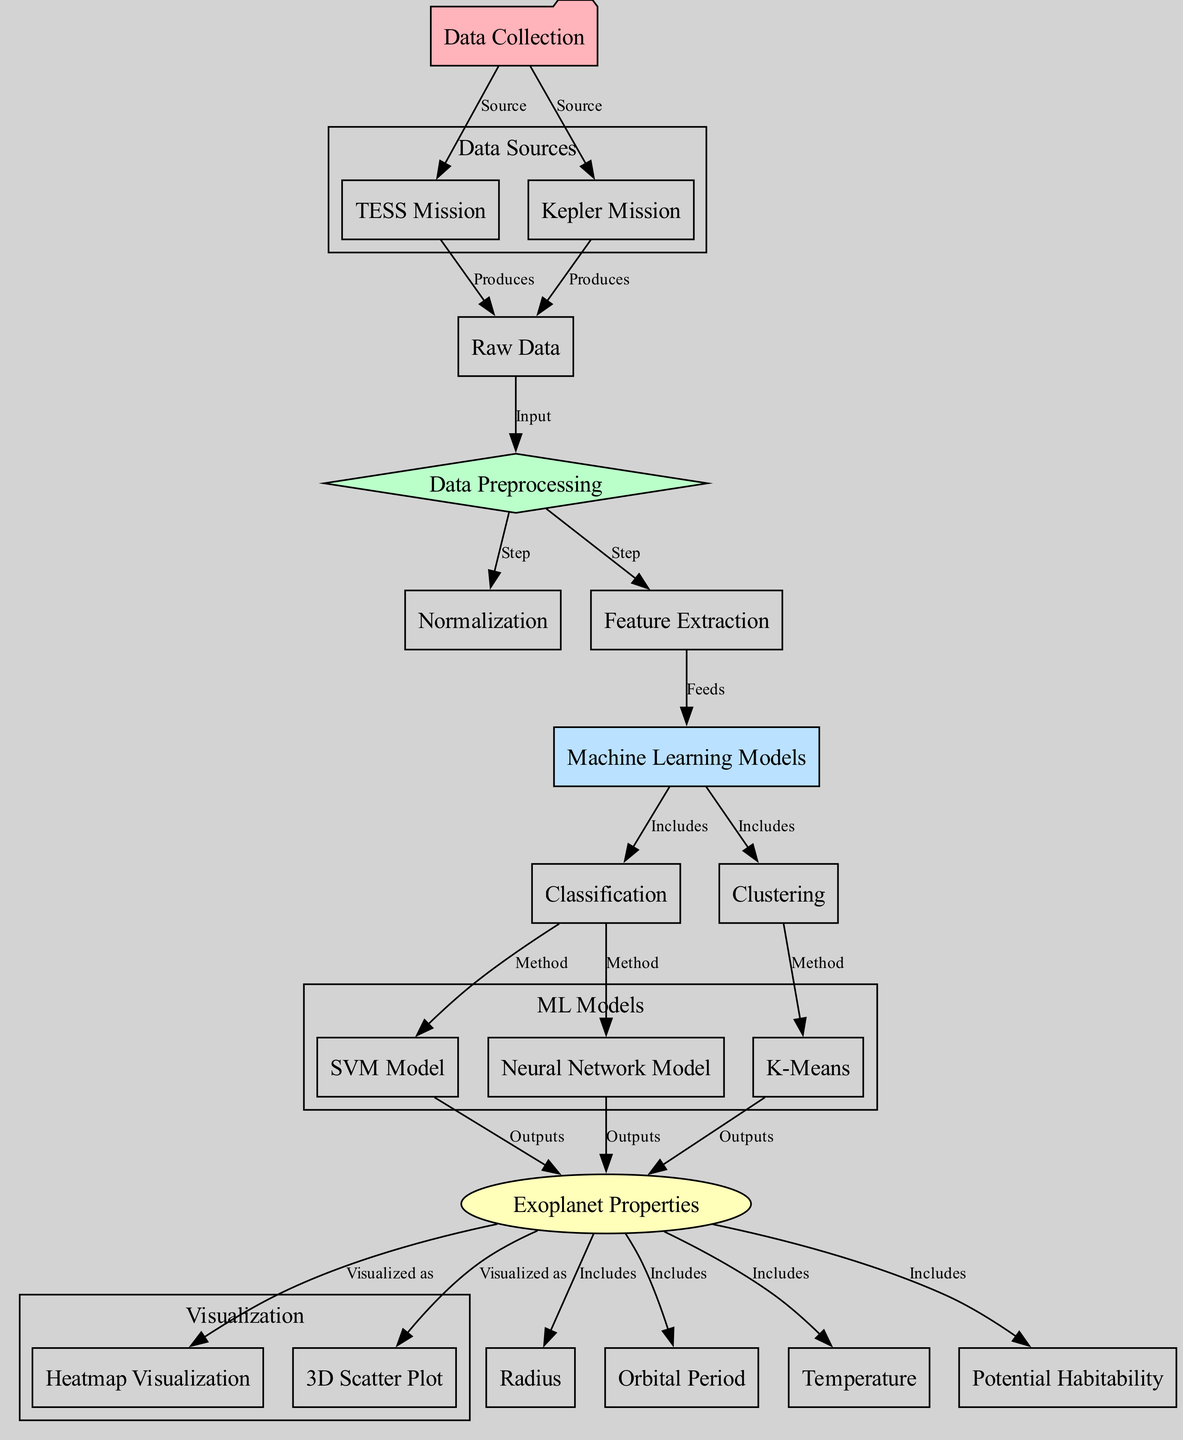What are the two main data sources represented in the diagram? The diagram lists the TESS Mission and Kepler Mission as data sources under the "Data Sources" subgraph, indicating they are the origins of the data collected for exoplanets.
Answer: TESS Mission, Kepler Mission How many nodes are present in the diagram? By counting all the nodes listed in the provided data, we find there are a total of 17 nodes related to the processes of data collection, preprocessing, machine learning models, and visualization.
Answer: 17 What is the preprocessing step that follows after raw data? The diagram indicates that after raw data is collected, it goes to the preprocessing step, which is shown as a direct connection indicating the flow of data.
Answer: Preprocessing Which machine learning model is classified as a clustering method? The diagram identifies the K-Means as a specific clustering method under the machine learning models section, as indicated by the directed edge linking clustering to K-Means.
Answer: K-Means How many output visualizations are produced from exoplanet properties? According to the diagram, the exoplanet properties lead to two visualization methods: heatmap visualization and 3D scatter plot, indicating multiple outputs from processed data.
Answer: 2 What is the classification method associated with the SVM model? The diagram links the SVM model directly to classification, indicating that the SVM is categorized as one of the methods used for classifying data related to exoplanets.
Answer: Method Which physical property is NOT included in the exoplanet properties visualization? The properties visualized include radius, orbital period, temperature, and potential habitability. However, any mentioned physical property not included and in context (e.g., mass) is absent as indicated in the diagram.
Answer: Mass What do the nodes labeled heatmap visualization and 3D scatter plot represent? These nodes represent different forms of data visualization used to display the physical properties of the exoplanets after they have been processed and classified, serving as outputs.
Answer: Visualization methods 